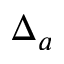Convert formula to latex. <formula><loc_0><loc_0><loc_500><loc_500>\Delta _ { a }</formula> 